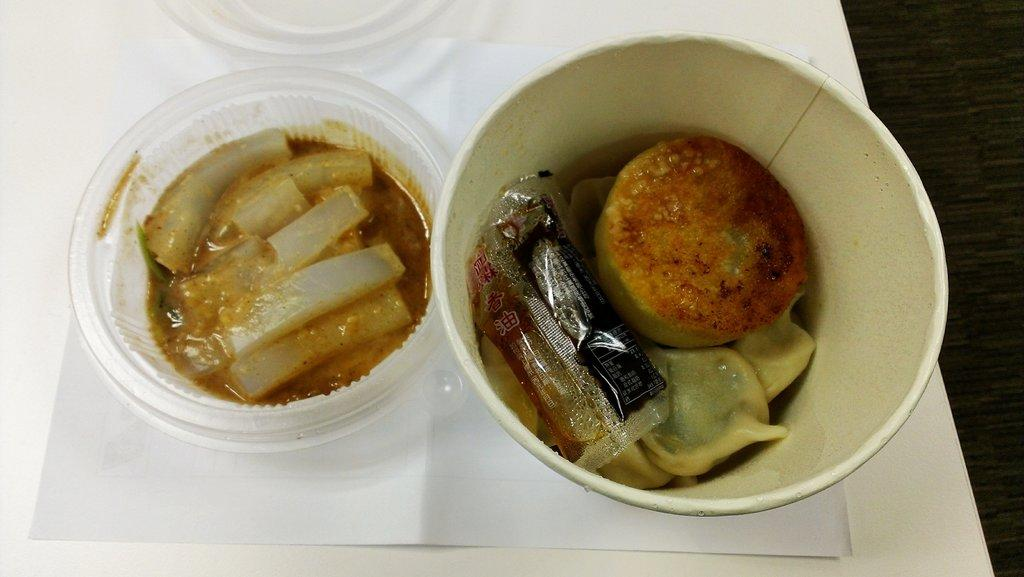Where was the image taken? The image was taken indoors. What can be seen on the right side of the image? There is a table on the right side of the image. What is placed on the table? There is a tray on the table. What is on the tray? There are two bowls with food items on the tray. What type of furniture can be seen in the jail in the image? There is no jail or furniture present in the image; it is taken indoors and features a table, tray, and bowls with food items. 